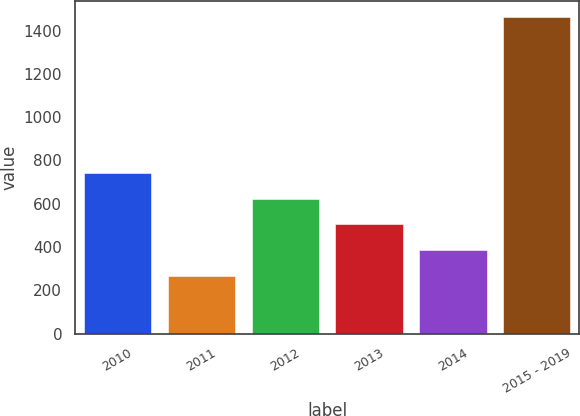Convert chart to OTSL. <chart><loc_0><loc_0><loc_500><loc_500><bar_chart><fcel>2010<fcel>2011<fcel>2012<fcel>2013<fcel>2014<fcel>2015 - 2019<nl><fcel>743.4<fcel>265<fcel>623.8<fcel>504.2<fcel>384.6<fcel>1461<nl></chart> 